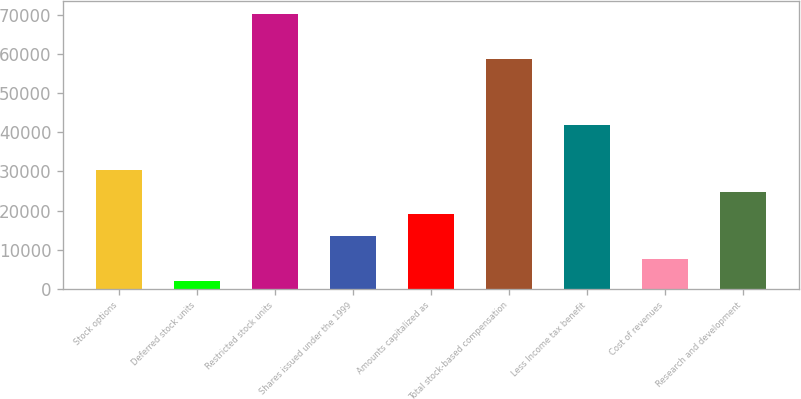<chart> <loc_0><loc_0><loc_500><loc_500><bar_chart><fcel>Stock options<fcel>Deferred stock units<fcel>Restricted stock units<fcel>Shares issued under the 1999<fcel>Amounts capitalized as<fcel>Total stock-based compensation<fcel>Less Income tax benefit<fcel>Cost of revenues<fcel>Research and development<nl><fcel>30441<fcel>2085<fcel>70139.4<fcel>13427.4<fcel>19098.6<fcel>58797<fcel>41783.4<fcel>7756.2<fcel>24769.8<nl></chart> 